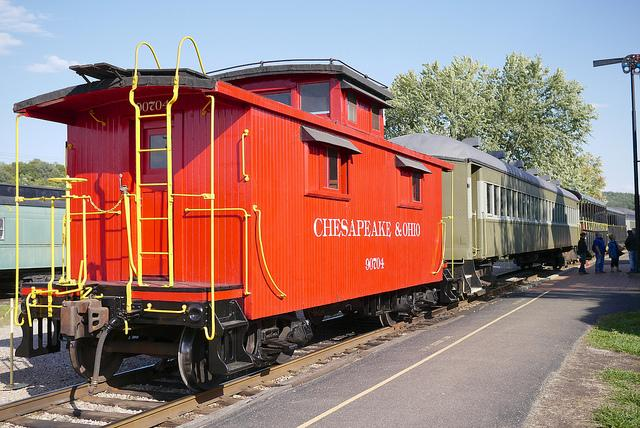The Chesapeake and Ohio Railway was a Class I railroad formed when? 1869 